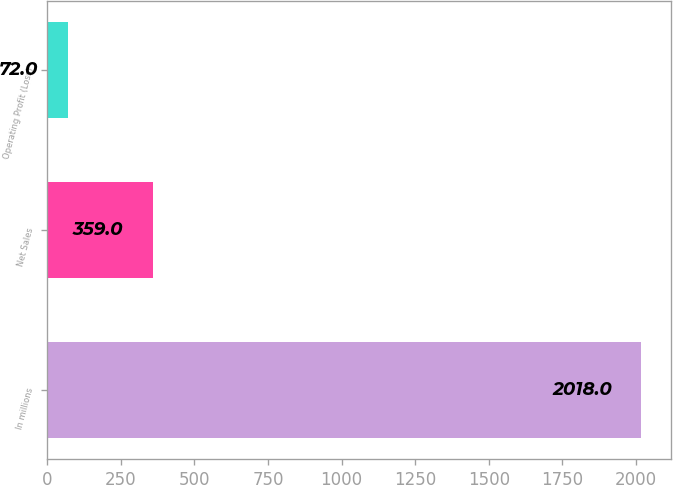<chart> <loc_0><loc_0><loc_500><loc_500><bar_chart><fcel>In millions<fcel>Net Sales<fcel>Operating Profit (Loss)<nl><fcel>2018<fcel>359<fcel>72<nl></chart> 